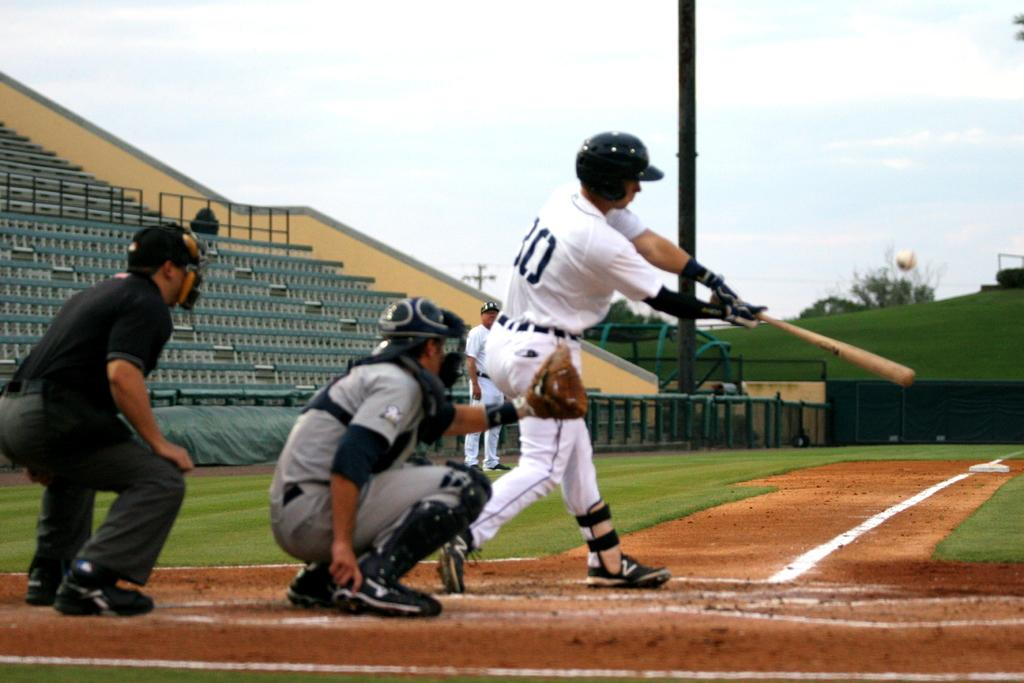Provide a one-sentence caption for the provided image. baseball player in white wearing number 30 or maybe 80 swings the bat at the ball. 